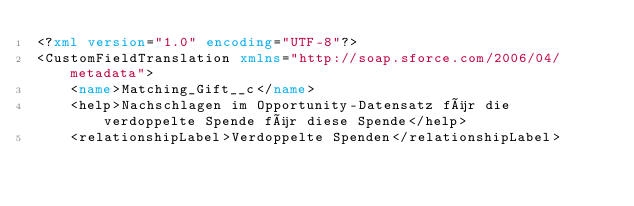Convert code to text. <code><loc_0><loc_0><loc_500><loc_500><_XML_><?xml version="1.0" encoding="UTF-8"?>
<CustomFieldTranslation xmlns="http://soap.sforce.com/2006/04/metadata">
    <name>Matching_Gift__c</name>
    <help>Nachschlagen im Opportunity-Datensatz für die verdoppelte Spende für diese Spende</help>
    <relationshipLabel>Verdoppelte Spenden</relationshipLabel></code> 